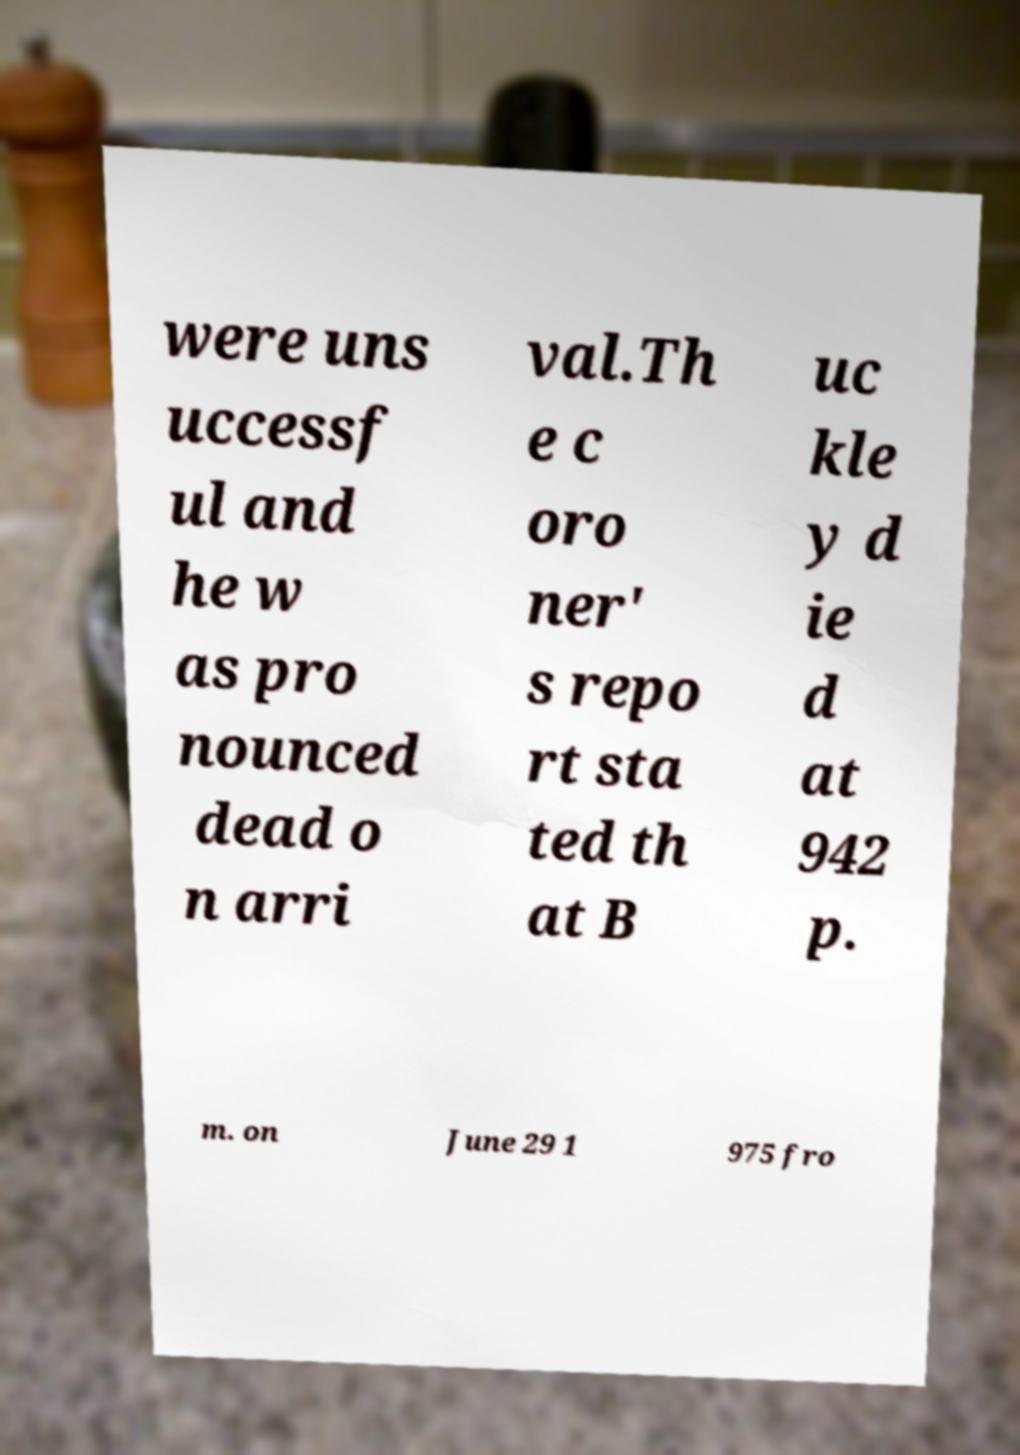Please identify and transcribe the text found in this image. were uns uccessf ul and he w as pro nounced dead o n arri val.Th e c oro ner' s repo rt sta ted th at B uc kle y d ie d at 942 p. m. on June 29 1 975 fro 